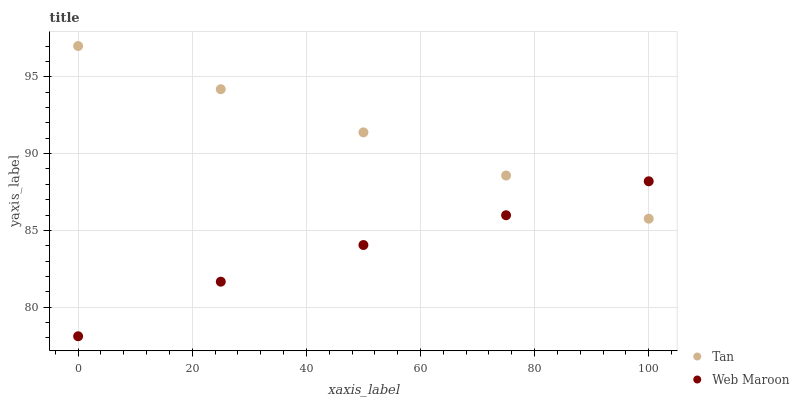Does Web Maroon have the minimum area under the curve?
Answer yes or no. Yes. Does Tan have the maximum area under the curve?
Answer yes or no. Yes. Does Web Maroon have the maximum area under the curve?
Answer yes or no. No. Is Tan the smoothest?
Answer yes or no. Yes. Is Web Maroon the roughest?
Answer yes or no. Yes. Is Web Maroon the smoothest?
Answer yes or no. No. Does Web Maroon have the lowest value?
Answer yes or no. Yes. Does Tan have the highest value?
Answer yes or no. Yes. Does Web Maroon have the highest value?
Answer yes or no. No. Does Tan intersect Web Maroon?
Answer yes or no. Yes. Is Tan less than Web Maroon?
Answer yes or no. No. Is Tan greater than Web Maroon?
Answer yes or no. No. 